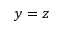Convert formula to latex. <formula><loc_0><loc_0><loc_500><loc_500>y = z</formula> 